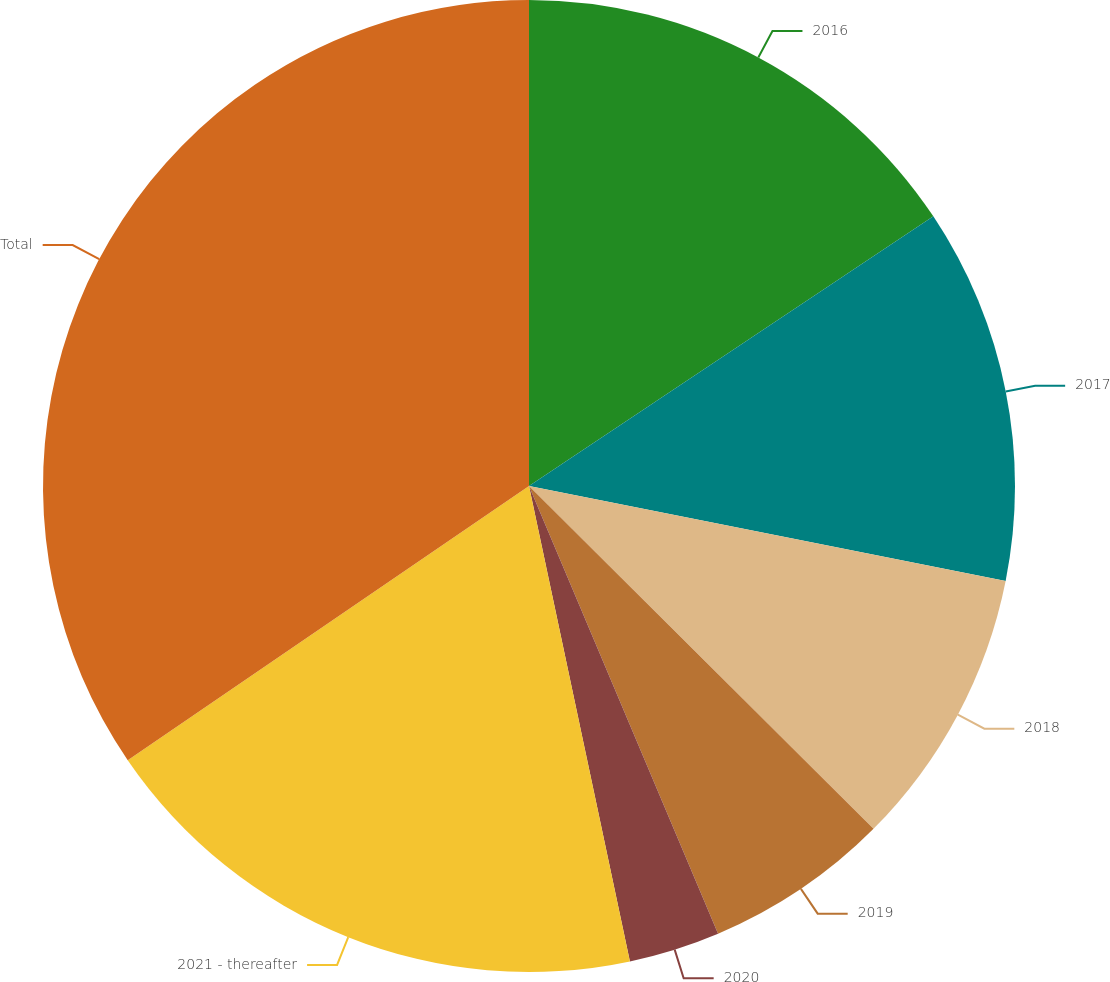Convert chart. <chart><loc_0><loc_0><loc_500><loc_500><pie_chart><fcel>2016<fcel>2017<fcel>2018<fcel>2019<fcel>2020<fcel>2021 - thereafter<fcel>Total<nl><fcel>15.64%<fcel>12.49%<fcel>9.33%<fcel>6.18%<fcel>3.03%<fcel>18.79%<fcel>34.54%<nl></chart> 